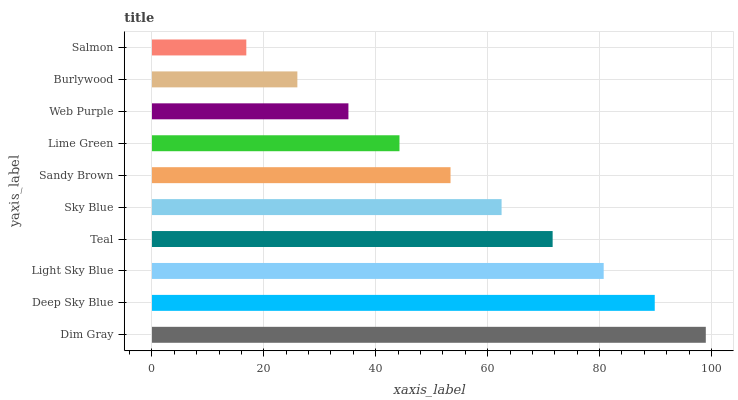Is Salmon the minimum?
Answer yes or no. Yes. Is Dim Gray the maximum?
Answer yes or no. Yes. Is Deep Sky Blue the minimum?
Answer yes or no. No. Is Deep Sky Blue the maximum?
Answer yes or no. No. Is Dim Gray greater than Deep Sky Blue?
Answer yes or no. Yes. Is Deep Sky Blue less than Dim Gray?
Answer yes or no. Yes. Is Deep Sky Blue greater than Dim Gray?
Answer yes or no. No. Is Dim Gray less than Deep Sky Blue?
Answer yes or no. No. Is Sky Blue the high median?
Answer yes or no. Yes. Is Sandy Brown the low median?
Answer yes or no. Yes. Is Light Sky Blue the high median?
Answer yes or no. No. Is Lime Green the low median?
Answer yes or no. No. 